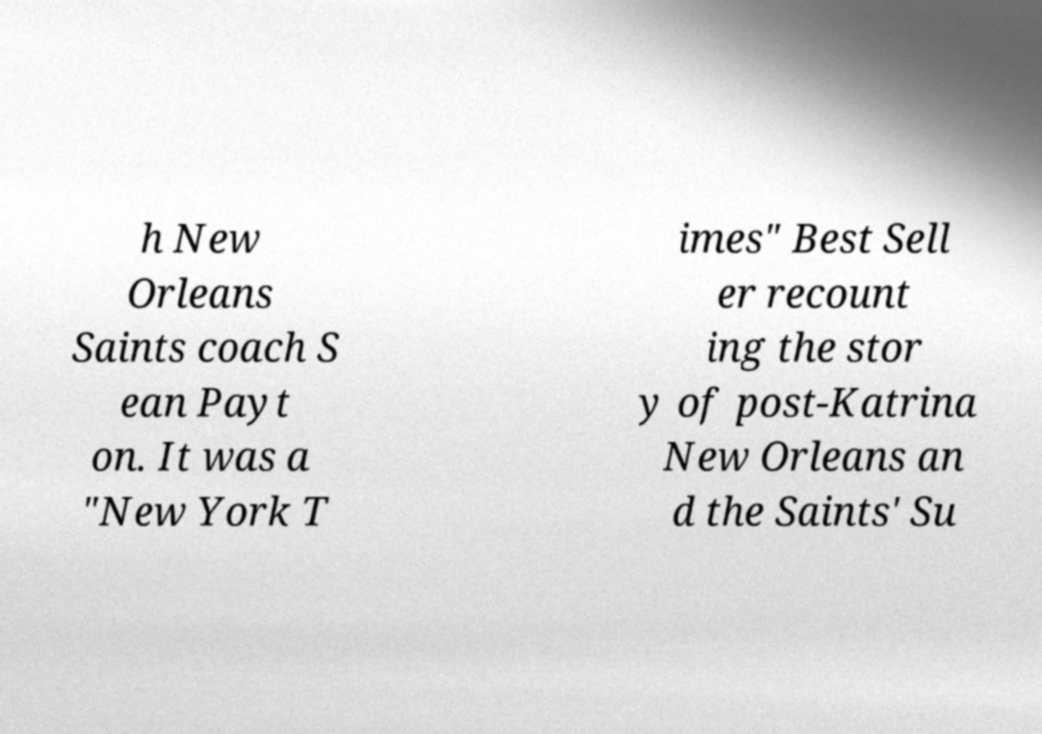Can you read and provide the text displayed in the image?This photo seems to have some interesting text. Can you extract and type it out for me? h New Orleans Saints coach S ean Payt on. It was a "New York T imes" Best Sell er recount ing the stor y of post-Katrina New Orleans an d the Saints' Su 